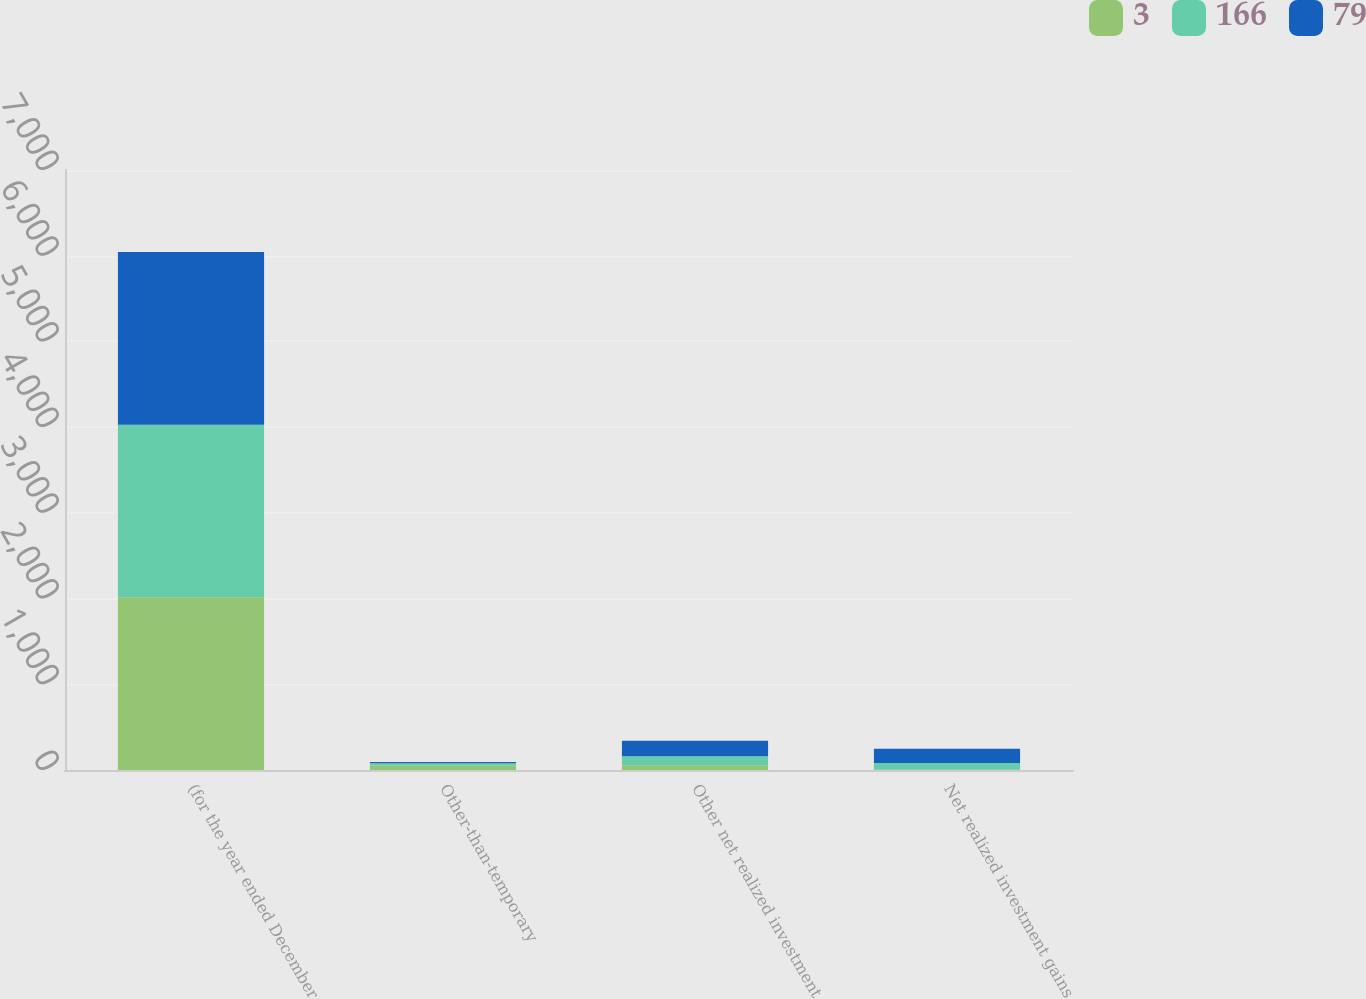Convert chart to OTSL. <chart><loc_0><loc_0><loc_500><loc_500><stacked_bar_chart><ecel><fcel>(for the year ended December<fcel>Other-than-temporary<fcel>Other net realized investment<fcel>Net realized investment gains<nl><fcel>3<fcel>2015<fcel>52<fcel>55<fcel>3<nl><fcel>166<fcel>2014<fcel>26<fcel>105<fcel>79<nl><fcel>79<fcel>2013<fcel>15<fcel>181<fcel>166<nl></chart> 